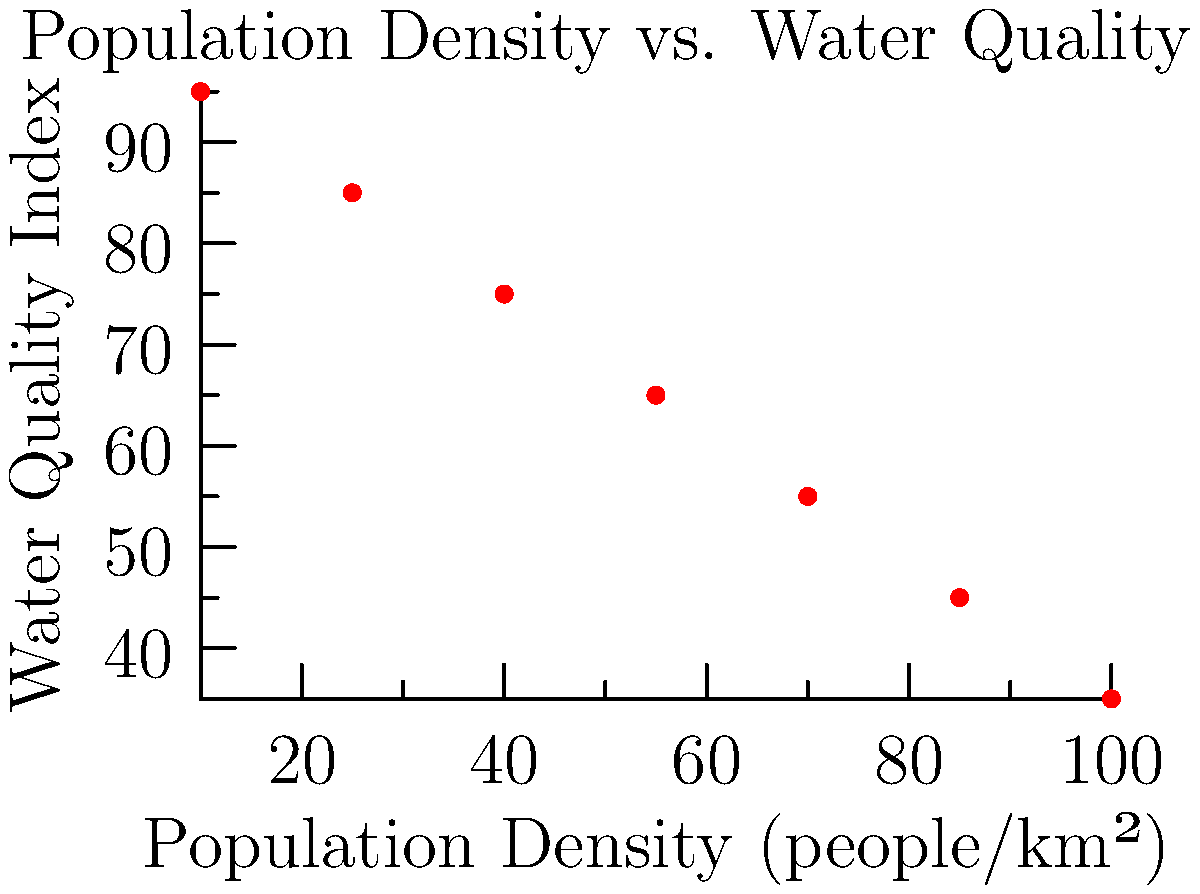Based on the scatter plot showing the relationship between population density and water quality in Canadian cities, estimate the correlation coefficient ($r$) and determine the strength and direction of the relationship. How might this information inform urban planning strategies to mitigate the environmental impact of industrialization? To estimate the correlation coefficient and analyze the relationship:

1. Observe the scatter plot:
   - Points form a clear downward trend from left to right.
   - The relationship appears to be strong and negative.

2. Estimate correlation coefficient ($r$):
   - Perfect negative correlation: $r = -1$
   - No correlation: $r = 0$
   - Perfect positive correlation: $r = 1$
   - Given the strong negative trend, estimate $r \approx -0.9$

3. Interpret the relationship:
   - Strong negative correlation: As population density increases, water quality decreases.
   - Strength: The relationship is strong due to the tight clustering of points around the trend.
   - Direction: Negative, indicating an inverse relationship.

4. Implications for urban planning:
   - Higher population density is associated with lower water quality.
   - Urban planners should consider:
     a. Implementing more effective wastewater treatment systems.
     b. Developing green infrastructure to filter runoff.
     c. Creating buffer zones between dense urban areas and water bodies.
     d. Encouraging sustainable industrial practices to reduce water pollution.

5. Limitations:
   - Correlation does not imply causation; other factors may influence water quality.
   - The sample size is small, so results should be interpreted cautiously.
   - Additional data and analysis would be needed for comprehensive urban planning strategies.
Answer: Strong negative correlation ($r \approx -0.9$) between population density and water quality, suggesting a need for improved urban water management strategies. 